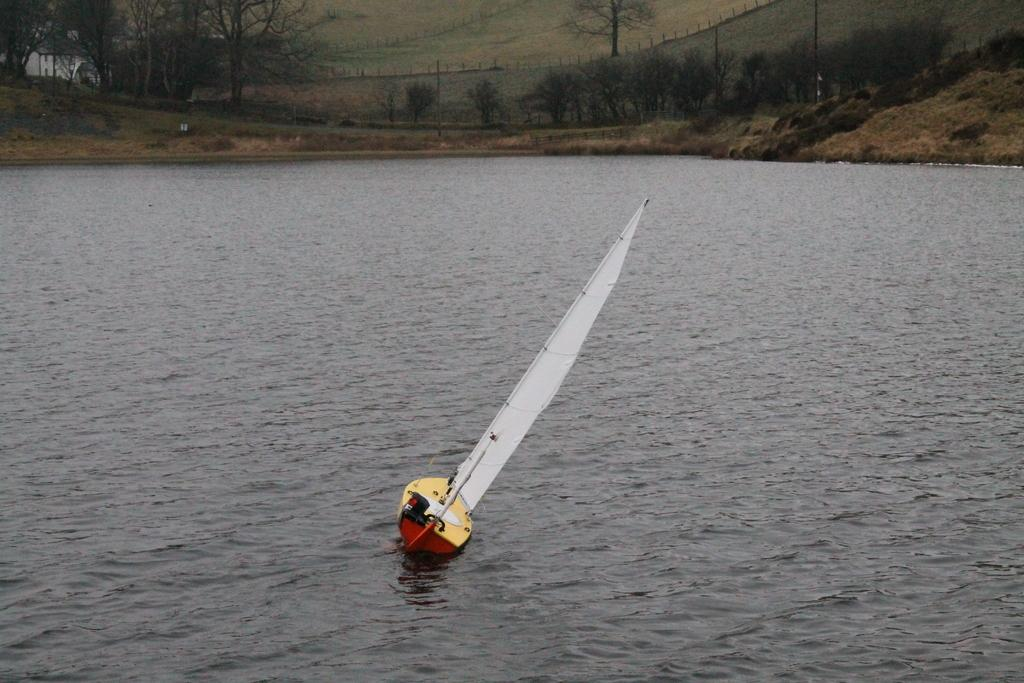What is the main subject of the image? The main subject of the image is a boat. Where is the boat located? The boat is on the water. What type of vegetation can be seen in the image? There are trees and grass visible in the image. What type of man-made structures are present in the image? There is a building and a wall present in the image. How many women are visible in the image? There are no women present in the image. What type of cabbage is being grown in the image? There is no cabbage present in the image. 